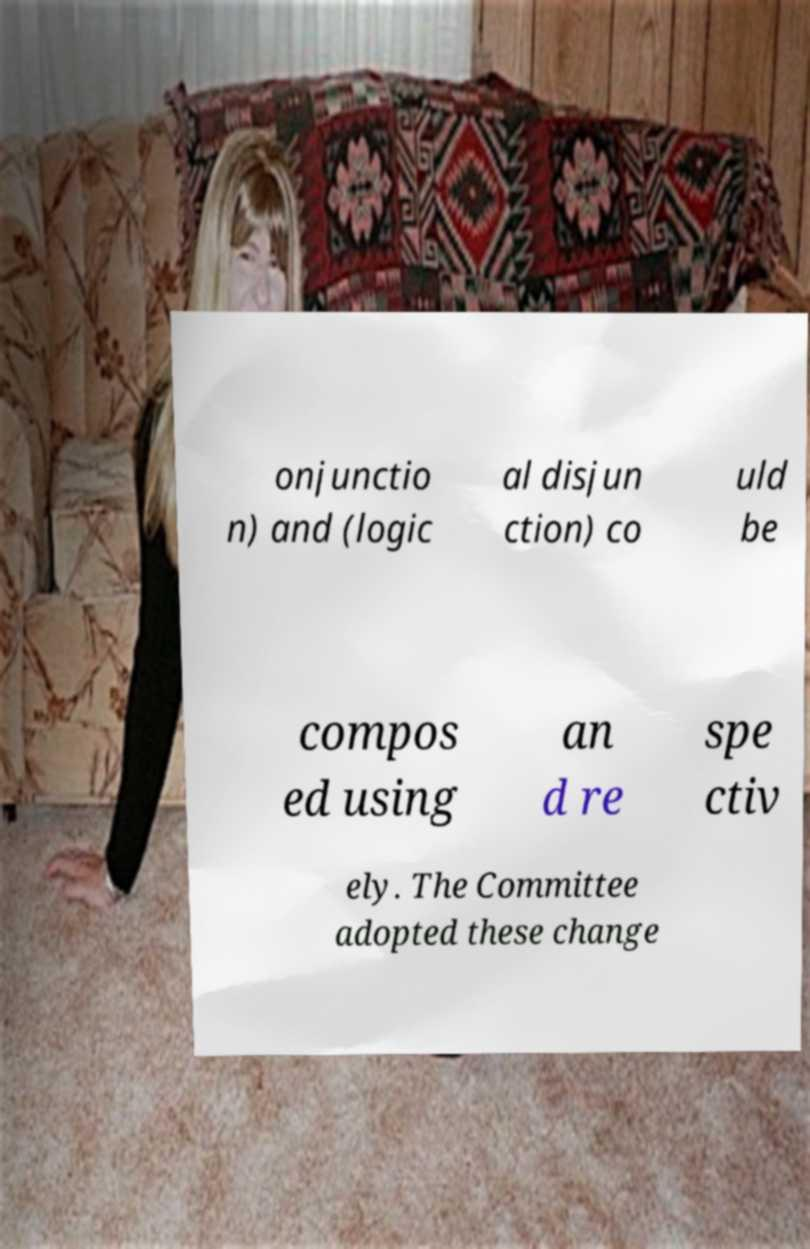Please identify and transcribe the text found in this image. onjunctio n) and (logic al disjun ction) co uld be compos ed using an d re spe ctiv ely. The Committee adopted these change 